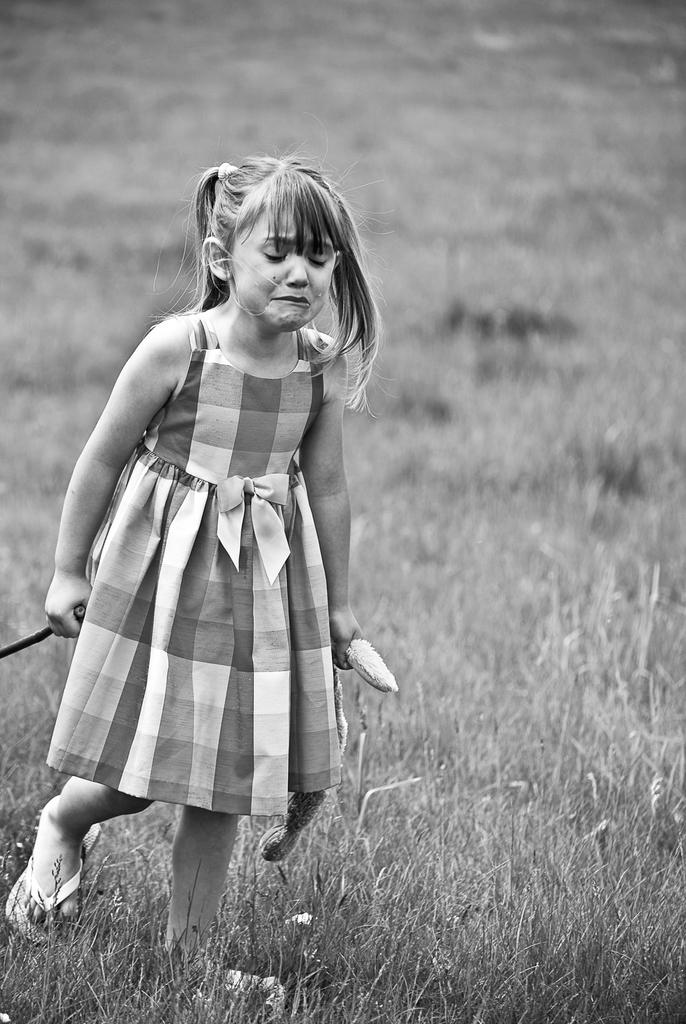What is the color scheme of the image? The image is black and white. Who is the main subject in the image? There is a child in the image. What is the child doing in the image? The child is holding objects. What can be seen in the background of the image? The background of the image includes ground covered with grass. What direction is the child facing in the image? The provided facts do not specify the direction the child is facing, so we cannot definitively answer this question. --- 